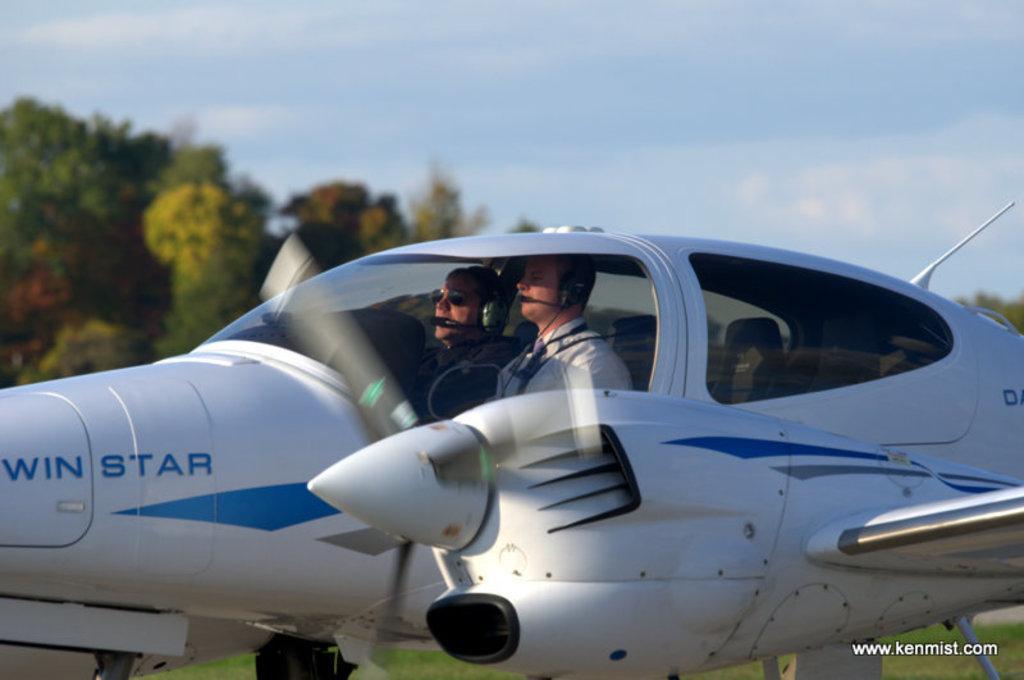How would you summarize this image in a sentence or two? This image consists of an airplane. It has wheels, wings, propeller. There are two persons sitting in that. There are trees on the left side. There is sky at the top. 